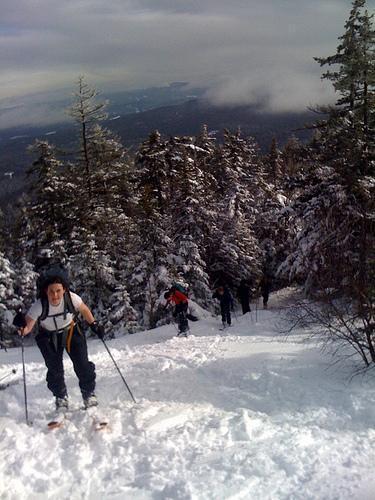How many skies are there?
Give a very brief answer. 5. 